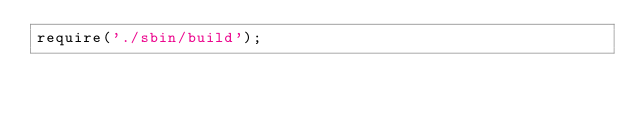Convert code to text. <code><loc_0><loc_0><loc_500><loc_500><_JavaScript_>require('./sbin/build');
</code> 